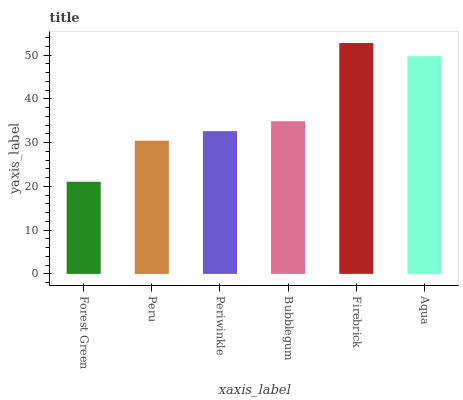Is Forest Green the minimum?
Answer yes or no. Yes. Is Firebrick the maximum?
Answer yes or no. Yes. Is Peru the minimum?
Answer yes or no. No. Is Peru the maximum?
Answer yes or no. No. Is Peru greater than Forest Green?
Answer yes or no. Yes. Is Forest Green less than Peru?
Answer yes or no. Yes. Is Forest Green greater than Peru?
Answer yes or no. No. Is Peru less than Forest Green?
Answer yes or no. No. Is Bubblegum the high median?
Answer yes or no. Yes. Is Periwinkle the low median?
Answer yes or no. Yes. Is Forest Green the high median?
Answer yes or no. No. Is Bubblegum the low median?
Answer yes or no. No. 